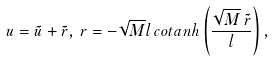Convert formula to latex. <formula><loc_0><loc_0><loc_500><loc_500>u = \tilde { u } + \tilde { r } , \, r = - \sqrt { M } l \, c o t a n h \left ( \frac { \sqrt { M } \, \tilde { r } } { l } \right ) ,</formula> 